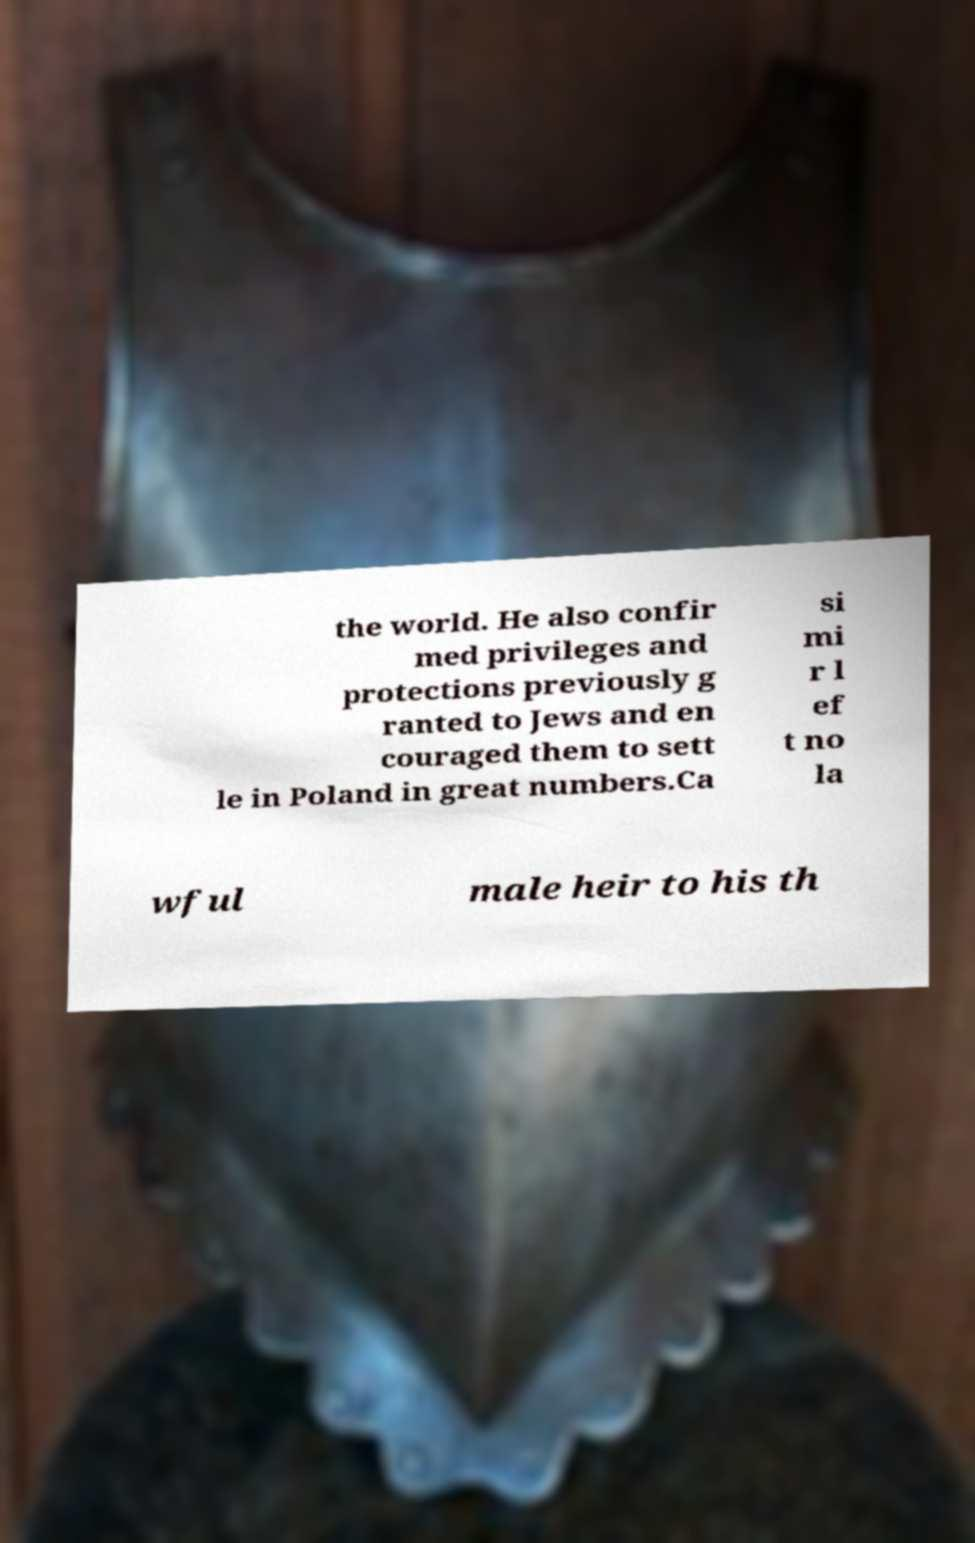Could you assist in decoding the text presented in this image and type it out clearly? the world. He also confir med privileges and protections previously g ranted to Jews and en couraged them to sett le in Poland in great numbers.Ca si mi r l ef t no la wful male heir to his th 